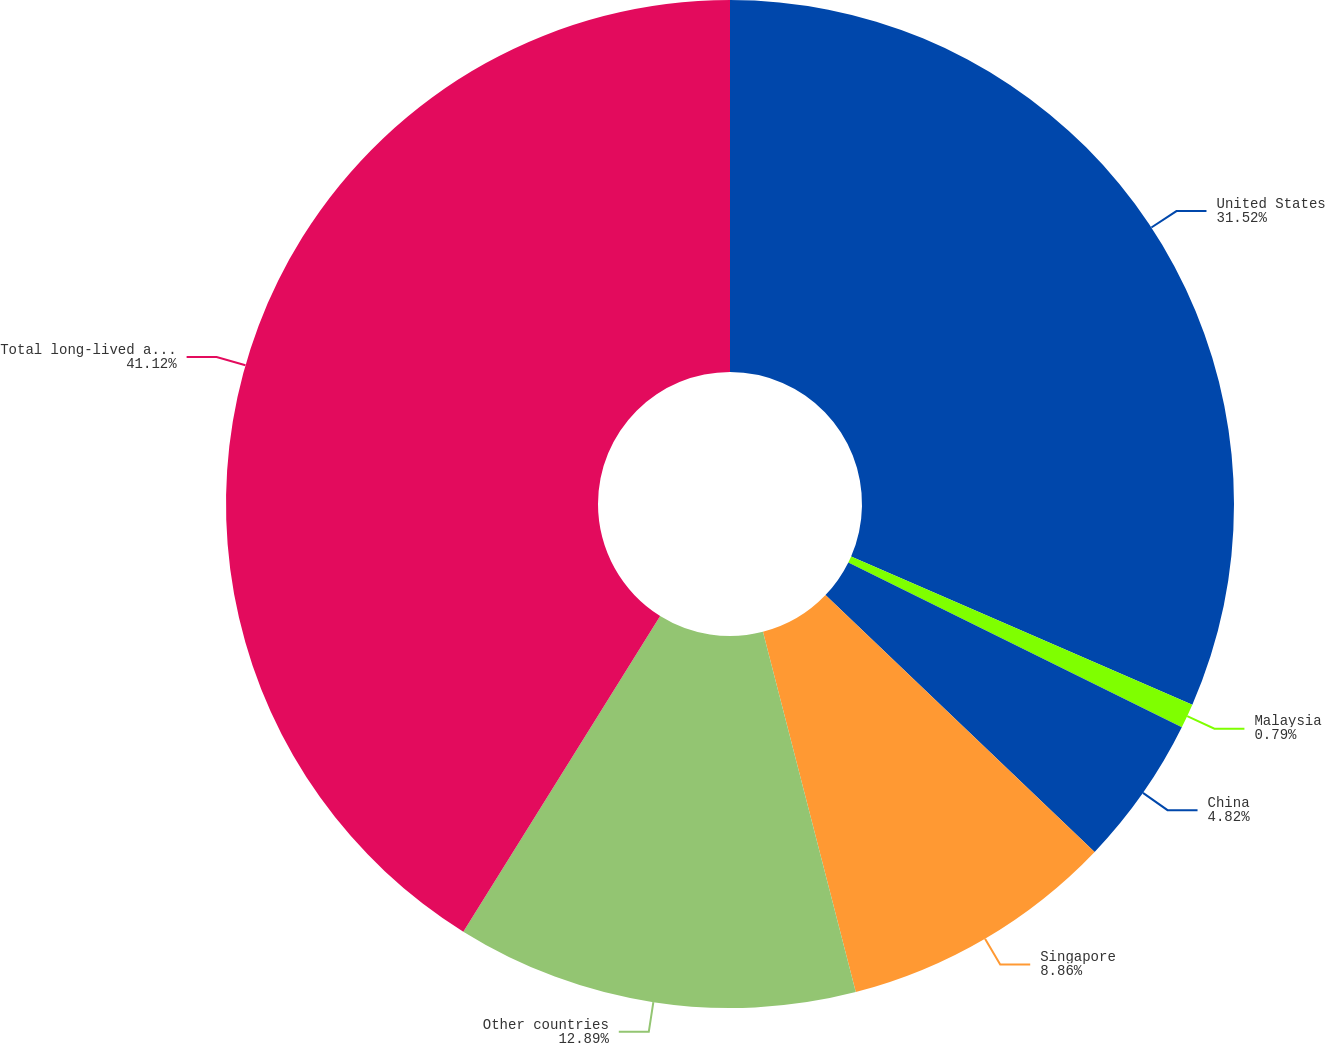Convert chart to OTSL. <chart><loc_0><loc_0><loc_500><loc_500><pie_chart><fcel>United States<fcel>Malaysia<fcel>China<fcel>Singapore<fcel>Other countries<fcel>Total long-lived assets<nl><fcel>31.52%<fcel>0.79%<fcel>4.82%<fcel>8.86%<fcel>12.89%<fcel>41.13%<nl></chart> 